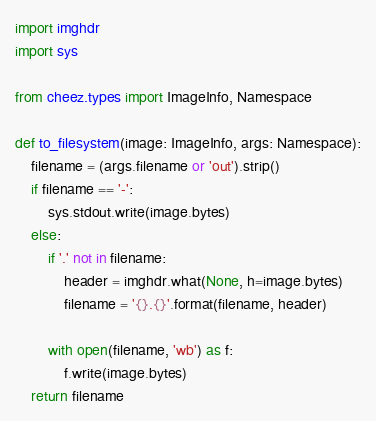Convert code to text. <code><loc_0><loc_0><loc_500><loc_500><_Python_>import imghdr
import sys

from cheez.types import ImageInfo, Namespace

def to_filesystem(image: ImageInfo, args: Namespace):
    filename = (args.filename or 'out').strip()
    if filename == '-':
        sys.stdout.write(image.bytes)
    else:
        if '.' not in filename:
            header = imghdr.what(None, h=image.bytes)
            filename = '{}.{}'.format(filename, header)

        with open(filename, 'wb') as f:
            f.write(image.bytes)
    return filename
</code> 